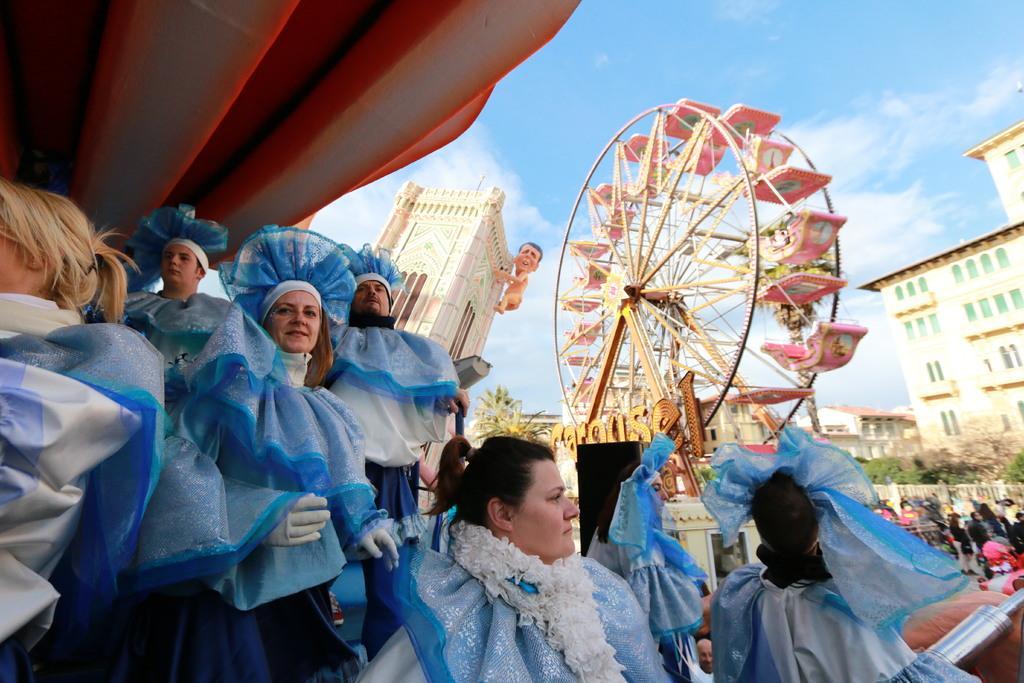Can you describe this image briefly? In this picture we can see a group of people, joint wheel, some objects and a statue of a man. In the background we can see trees, buildings and the sky. 